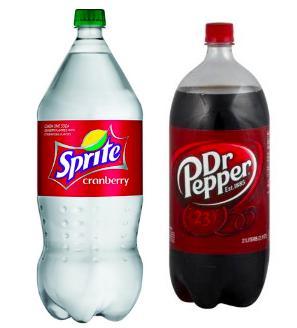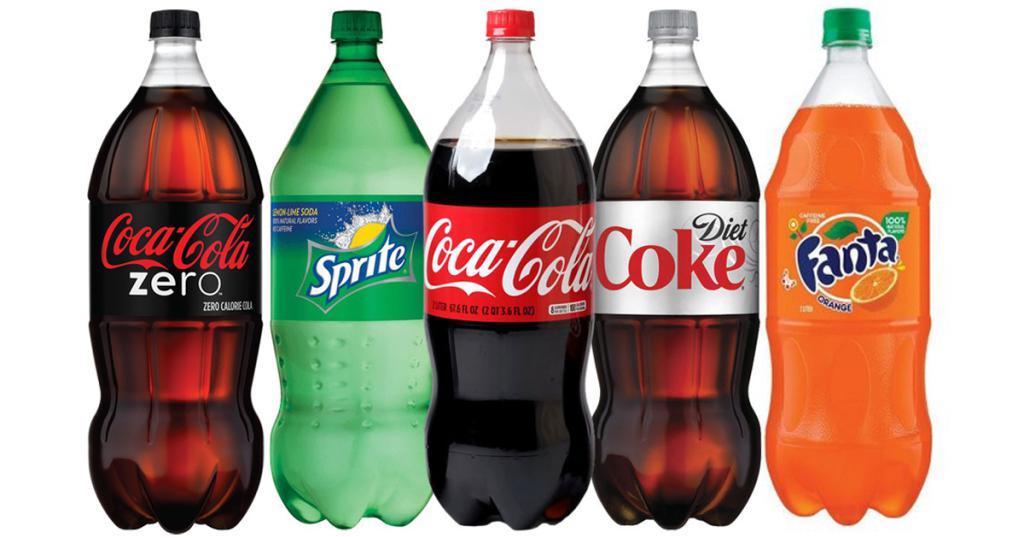The first image is the image on the left, the second image is the image on the right. Considering the images on both sides, is "The combined images contain seven soda bottles, and no two bottles are exactly the same." valid? Answer yes or no. Yes. 